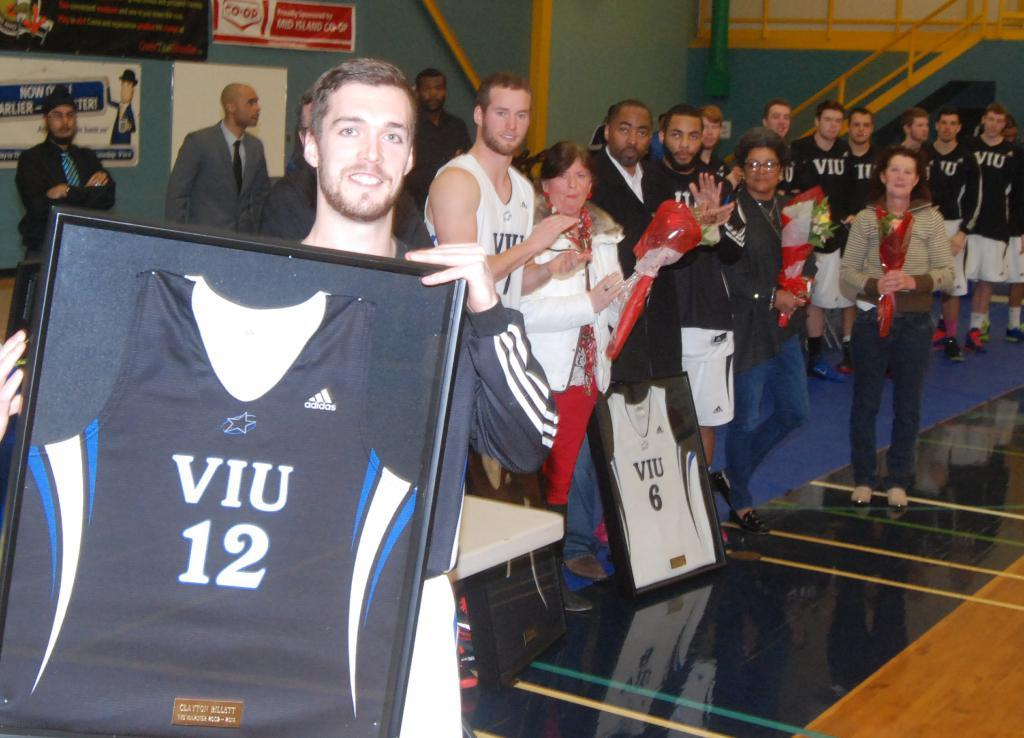Provide a one-sentence caption for the provided image. A man holding a picture of a shirt with Viu 12 written on it. 